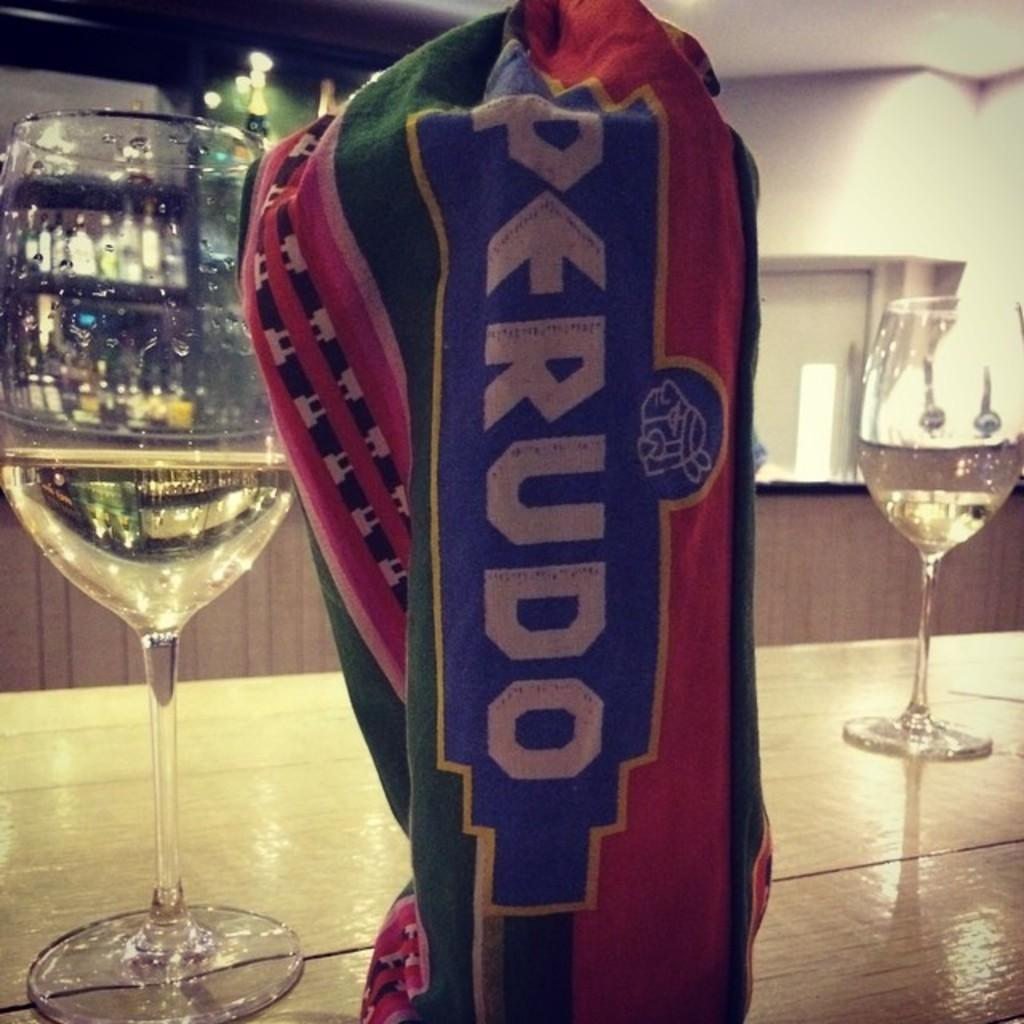Provide a one-sentence caption for the provided image. A countertop with a couple of wine glasses and a coloful Perudo cloth bag. 